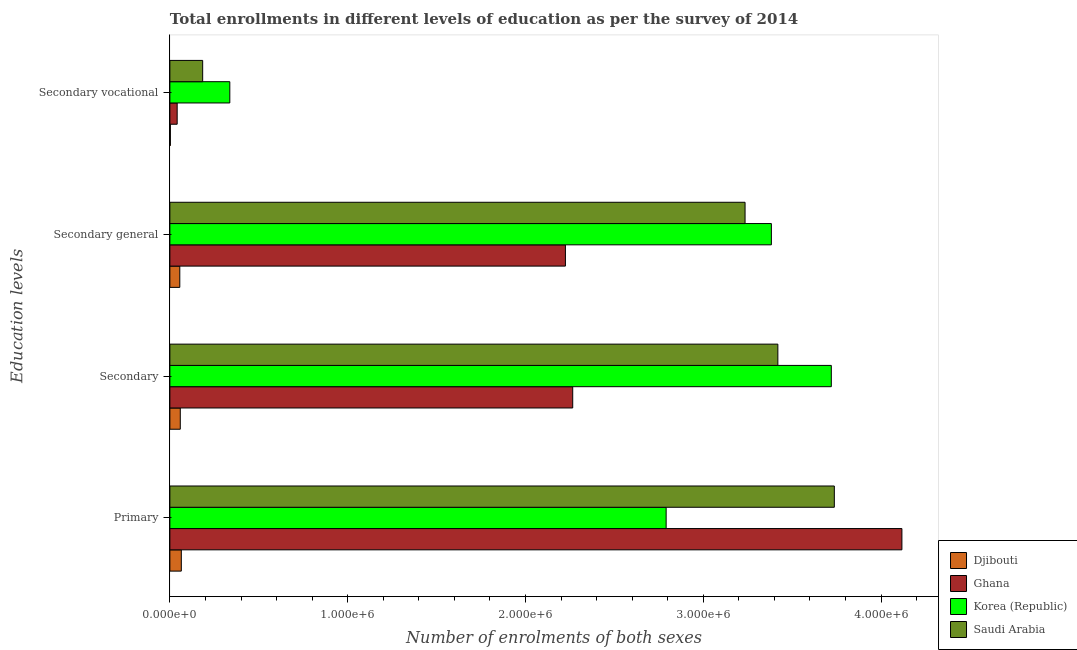How many different coloured bars are there?
Offer a terse response. 4. Are the number of bars per tick equal to the number of legend labels?
Provide a short and direct response. Yes. Are the number of bars on each tick of the Y-axis equal?
Keep it short and to the point. Yes. How many bars are there on the 4th tick from the top?
Ensure brevity in your answer.  4. What is the label of the 3rd group of bars from the top?
Keep it short and to the point. Secondary. What is the number of enrolments in secondary vocational education in Djibouti?
Your answer should be compact. 2728. Across all countries, what is the maximum number of enrolments in secondary education?
Provide a succinct answer. 3.72e+06. Across all countries, what is the minimum number of enrolments in primary education?
Give a very brief answer. 6.43e+04. In which country was the number of enrolments in secondary education maximum?
Your answer should be compact. Korea (Republic). In which country was the number of enrolments in secondary education minimum?
Provide a short and direct response. Djibouti. What is the total number of enrolments in primary education in the graph?
Provide a succinct answer. 1.07e+07. What is the difference between the number of enrolments in secondary education in Ghana and that in Korea (Republic)?
Make the answer very short. -1.45e+06. What is the difference between the number of enrolments in primary education in Djibouti and the number of enrolments in secondary vocational education in Korea (Republic)?
Ensure brevity in your answer.  -2.73e+05. What is the average number of enrolments in primary education per country?
Your response must be concise. 2.68e+06. What is the difference between the number of enrolments in secondary vocational education and number of enrolments in secondary education in Korea (Republic)?
Your answer should be compact. -3.38e+06. What is the ratio of the number of enrolments in primary education in Korea (Republic) to that in Djibouti?
Provide a short and direct response. 43.4. Is the number of enrolments in secondary general education in Djibouti less than that in Ghana?
Keep it short and to the point. Yes. Is the difference between the number of enrolments in primary education in Ghana and Korea (Republic) greater than the difference between the number of enrolments in secondary general education in Ghana and Korea (Republic)?
Keep it short and to the point. Yes. What is the difference between the highest and the second highest number of enrolments in secondary education?
Give a very brief answer. 3.01e+05. What is the difference between the highest and the lowest number of enrolments in secondary education?
Provide a short and direct response. 3.66e+06. What does the 4th bar from the bottom in Secondary vocational represents?
Offer a very short reply. Saudi Arabia. Is it the case that in every country, the sum of the number of enrolments in primary education and number of enrolments in secondary education is greater than the number of enrolments in secondary general education?
Give a very brief answer. Yes. Are the values on the major ticks of X-axis written in scientific E-notation?
Offer a very short reply. Yes. Where does the legend appear in the graph?
Offer a terse response. Bottom right. How are the legend labels stacked?
Ensure brevity in your answer.  Vertical. What is the title of the graph?
Your answer should be very brief. Total enrollments in different levels of education as per the survey of 2014. What is the label or title of the X-axis?
Offer a very short reply. Number of enrolments of both sexes. What is the label or title of the Y-axis?
Ensure brevity in your answer.  Education levels. What is the Number of enrolments of both sexes in Djibouti in Primary?
Your answer should be very brief. 6.43e+04. What is the Number of enrolments of both sexes of Ghana in Primary?
Offer a very short reply. 4.12e+06. What is the Number of enrolments of both sexes of Korea (Republic) in Primary?
Make the answer very short. 2.79e+06. What is the Number of enrolments of both sexes in Saudi Arabia in Primary?
Give a very brief answer. 3.74e+06. What is the Number of enrolments of both sexes in Djibouti in Secondary?
Your answer should be very brief. 5.86e+04. What is the Number of enrolments of both sexes in Ghana in Secondary?
Your answer should be very brief. 2.27e+06. What is the Number of enrolments of both sexes of Korea (Republic) in Secondary?
Offer a terse response. 3.72e+06. What is the Number of enrolments of both sexes in Saudi Arabia in Secondary?
Keep it short and to the point. 3.42e+06. What is the Number of enrolments of both sexes of Djibouti in Secondary general?
Keep it short and to the point. 5.58e+04. What is the Number of enrolments of both sexes of Ghana in Secondary general?
Your answer should be compact. 2.22e+06. What is the Number of enrolments of both sexes in Korea (Republic) in Secondary general?
Your answer should be compact. 3.38e+06. What is the Number of enrolments of both sexes of Saudi Arabia in Secondary general?
Your answer should be compact. 3.24e+06. What is the Number of enrolments of both sexes of Djibouti in Secondary vocational?
Offer a terse response. 2728. What is the Number of enrolments of both sexes of Ghana in Secondary vocational?
Keep it short and to the point. 4.11e+04. What is the Number of enrolments of both sexes in Korea (Republic) in Secondary vocational?
Offer a terse response. 3.37e+05. What is the Number of enrolments of both sexes in Saudi Arabia in Secondary vocational?
Provide a succinct answer. 1.84e+05. Across all Education levels, what is the maximum Number of enrolments of both sexes of Djibouti?
Give a very brief answer. 6.43e+04. Across all Education levels, what is the maximum Number of enrolments of both sexes of Ghana?
Keep it short and to the point. 4.12e+06. Across all Education levels, what is the maximum Number of enrolments of both sexes in Korea (Republic)?
Your response must be concise. 3.72e+06. Across all Education levels, what is the maximum Number of enrolments of both sexes in Saudi Arabia?
Provide a succinct answer. 3.74e+06. Across all Education levels, what is the minimum Number of enrolments of both sexes in Djibouti?
Offer a terse response. 2728. Across all Education levels, what is the minimum Number of enrolments of both sexes in Ghana?
Your answer should be compact. 4.11e+04. Across all Education levels, what is the minimum Number of enrolments of both sexes of Korea (Republic)?
Provide a succinct answer. 3.37e+05. Across all Education levels, what is the minimum Number of enrolments of both sexes of Saudi Arabia?
Your answer should be compact. 1.84e+05. What is the total Number of enrolments of both sexes of Djibouti in the graph?
Offer a very short reply. 1.81e+05. What is the total Number of enrolments of both sexes in Ghana in the graph?
Offer a very short reply. 8.65e+06. What is the total Number of enrolments of both sexes of Korea (Republic) in the graph?
Provide a short and direct response. 1.02e+07. What is the total Number of enrolments of both sexes of Saudi Arabia in the graph?
Provide a short and direct response. 1.06e+07. What is the difference between the Number of enrolments of both sexes in Djibouti in Primary and that in Secondary?
Offer a terse response. 5766. What is the difference between the Number of enrolments of both sexes of Ghana in Primary and that in Secondary?
Provide a short and direct response. 1.85e+06. What is the difference between the Number of enrolments of both sexes of Korea (Republic) in Primary and that in Secondary?
Offer a terse response. -9.29e+05. What is the difference between the Number of enrolments of both sexes of Saudi Arabia in Primary and that in Secondary?
Keep it short and to the point. 3.18e+05. What is the difference between the Number of enrolments of both sexes in Djibouti in Primary and that in Secondary general?
Provide a succinct answer. 8494. What is the difference between the Number of enrolments of both sexes of Ghana in Primary and that in Secondary general?
Provide a succinct answer. 1.89e+06. What is the difference between the Number of enrolments of both sexes of Korea (Republic) in Primary and that in Secondary general?
Offer a very short reply. -5.92e+05. What is the difference between the Number of enrolments of both sexes of Saudi Arabia in Primary and that in Secondary general?
Provide a succinct answer. 5.02e+05. What is the difference between the Number of enrolments of both sexes in Djibouti in Primary and that in Secondary vocational?
Your response must be concise. 6.16e+04. What is the difference between the Number of enrolments of both sexes of Ghana in Primary and that in Secondary vocational?
Make the answer very short. 4.08e+06. What is the difference between the Number of enrolments of both sexes in Korea (Republic) in Primary and that in Secondary vocational?
Offer a very short reply. 2.45e+06. What is the difference between the Number of enrolments of both sexes of Saudi Arabia in Primary and that in Secondary vocational?
Make the answer very short. 3.55e+06. What is the difference between the Number of enrolments of both sexes in Djibouti in Secondary and that in Secondary general?
Ensure brevity in your answer.  2728. What is the difference between the Number of enrolments of both sexes in Ghana in Secondary and that in Secondary general?
Your answer should be very brief. 4.11e+04. What is the difference between the Number of enrolments of both sexes of Korea (Republic) in Secondary and that in Secondary general?
Your answer should be compact. 3.37e+05. What is the difference between the Number of enrolments of both sexes in Saudi Arabia in Secondary and that in Secondary general?
Your response must be concise. 1.84e+05. What is the difference between the Number of enrolments of both sexes in Djibouti in Secondary and that in Secondary vocational?
Ensure brevity in your answer.  5.58e+04. What is the difference between the Number of enrolments of both sexes in Ghana in Secondary and that in Secondary vocational?
Keep it short and to the point. 2.22e+06. What is the difference between the Number of enrolments of both sexes in Korea (Republic) in Secondary and that in Secondary vocational?
Ensure brevity in your answer.  3.38e+06. What is the difference between the Number of enrolments of both sexes of Saudi Arabia in Secondary and that in Secondary vocational?
Your response must be concise. 3.24e+06. What is the difference between the Number of enrolments of both sexes of Djibouti in Secondary general and that in Secondary vocational?
Make the answer very short. 5.31e+04. What is the difference between the Number of enrolments of both sexes in Ghana in Secondary general and that in Secondary vocational?
Keep it short and to the point. 2.18e+06. What is the difference between the Number of enrolments of both sexes in Korea (Republic) in Secondary general and that in Secondary vocational?
Your response must be concise. 3.05e+06. What is the difference between the Number of enrolments of both sexes of Saudi Arabia in Secondary general and that in Secondary vocational?
Offer a very short reply. 3.05e+06. What is the difference between the Number of enrolments of both sexes of Djibouti in Primary and the Number of enrolments of both sexes of Ghana in Secondary?
Keep it short and to the point. -2.20e+06. What is the difference between the Number of enrolments of both sexes of Djibouti in Primary and the Number of enrolments of both sexes of Korea (Republic) in Secondary?
Your answer should be very brief. -3.66e+06. What is the difference between the Number of enrolments of both sexes of Djibouti in Primary and the Number of enrolments of both sexes of Saudi Arabia in Secondary?
Provide a succinct answer. -3.36e+06. What is the difference between the Number of enrolments of both sexes in Ghana in Primary and the Number of enrolments of both sexes in Korea (Republic) in Secondary?
Keep it short and to the point. 3.97e+05. What is the difference between the Number of enrolments of both sexes in Ghana in Primary and the Number of enrolments of both sexes in Saudi Arabia in Secondary?
Your response must be concise. 6.98e+05. What is the difference between the Number of enrolments of both sexes in Korea (Republic) in Primary and the Number of enrolments of both sexes in Saudi Arabia in Secondary?
Make the answer very short. -6.28e+05. What is the difference between the Number of enrolments of both sexes of Djibouti in Primary and the Number of enrolments of both sexes of Ghana in Secondary general?
Your response must be concise. -2.16e+06. What is the difference between the Number of enrolments of both sexes of Djibouti in Primary and the Number of enrolments of both sexes of Korea (Republic) in Secondary general?
Provide a succinct answer. -3.32e+06. What is the difference between the Number of enrolments of both sexes in Djibouti in Primary and the Number of enrolments of both sexes in Saudi Arabia in Secondary general?
Offer a very short reply. -3.17e+06. What is the difference between the Number of enrolments of both sexes in Ghana in Primary and the Number of enrolments of both sexes in Korea (Republic) in Secondary general?
Keep it short and to the point. 7.34e+05. What is the difference between the Number of enrolments of both sexes in Ghana in Primary and the Number of enrolments of both sexes in Saudi Arabia in Secondary general?
Keep it short and to the point. 8.82e+05. What is the difference between the Number of enrolments of both sexes in Korea (Republic) in Primary and the Number of enrolments of both sexes in Saudi Arabia in Secondary general?
Give a very brief answer. -4.44e+05. What is the difference between the Number of enrolments of both sexes in Djibouti in Primary and the Number of enrolments of both sexes in Ghana in Secondary vocational?
Give a very brief answer. 2.33e+04. What is the difference between the Number of enrolments of both sexes of Djibouti in Primary and the Number of enrolments of both sexes of Korea (Republic) in Secondary vocational?
Your answer should be compact. -2.73e+05. What is the difference between the Number of enrolments of both sexes in Djibouti in Primary and the Number of enrolments of both sexes in Saudi Arabia in Secondary vocational?
Offer a very short reply. -1.20e+05. What is the difference between the Number of enrolments of both sexes in Ghana in Primary and the Number of enrolments of both sexes in Korea (Republic) in Secondary vocational?
Provide a succinct answer. 3.78e+06. What is the difference between the Number of enrolments of both sexes in Ghana in Primary and the Number of enrolments of both sexes in Saudi Arabia in Secondary vocational?
Offer a terse response. 3.93e+06. What is the difference between the Number of enrolments of both sexes in Korea (Republic) in Primary and the Number of enrolments of both sexes in Saudi Arabia in Secondary vocational?
Ensure brevity in your answer.  2.61e+06. What is the difference between the Number of enrolments of both sexes of Djibouti in Secondary and the Number of enrolments of both sexes of Ghana in Secondary general?
Keep it short and to the point. -2.17e+06. What is the difference between the Number of enrolments of both sexes of Djibouti in Secondary and the Number of enrolments of both sexes of Korea (Republic) in Secondary general?
Make the answer very short. -3.32e+06. What is the difference between the Number of enrolments of both sexes in Djibouti in Secondary and the Number of enrolments of both sexes in Saudi Arabia in Secondary general?
Keep it short and to the point. -3.18e+06. What is the difference between the Number of enrolments of both sexes of Ghana in Secondary and the Number of enrolments of both sexes of Korea (Republic) in Secondary general?
Offer a terse response. -1.12e+06. What is the difference between the Number of enrolments of both sexes of Ghana in Secondary and the Number of enrolments of both sexes of Saudi Arabia in Secondary general?
Ensure brevity in your answer.  -9.69e+05. What is the difference between the Number of enrolments of both sexes of Korea (Republic) in Secondary and the Number of enrolments of both sexes of Saudi Arabia in Secondary general?
Make the answer very short. 4.85e+05. What is the difference between the Number of enrolments of both sexes of Djibouti in Secondary and the Number of enrolments of both sexes of Ghana in Secondary vocational?
Ensure brevity in your answer.  1.75e+04. What is the difference between the Number of enrolments of both sexes of Djibouti in Secondary and the Number of enrolments of both sexes of Korea (Republic) in Secondary vocational?
Provide a succinct answer. -2.79e+05. What is the difference between the Number of enrolments of both sexes in Djibouti in Secondary and the Number of enrolments of both sexes in Saudi Arabia in Secondary vocational?
Offer a very short reply. -1.26e+05. What is the difference between the Number of enrolments of both sexes in Ghana in Secondary and the Number of enrolments of both sexes in Korea (Republic) in Secondary vocational?
Your answer should be compact. 1.93e+06. What is the difference between the Number of enrolments of both sexes of Ghana in Secondary and the Number of enrolments of both sexes of Saudi Arabia in Secondary vocational?
Ensure brevity in your answer.  2.08e+06. What is the difference between the Number of enrolments of both sexes in Korea (Republic) in Secondary and the Number of enrolments of both sexes in Saudi Arabia in Secondary vocational?
Provide a short and direct response. 3.54e+06. What is the difference between the Number of enrolments of both sexes of Djibouti in Secondary general and the Number of enrolments of both sexes of Ghana in Secondary vocational?
Give a very brief answer. 1.48e+04. What is the difference between the Number of enrolments of both sexes of Djibouti in Secondary general and the Number of enrolments of both sexes of Korea (Republic) in Secondary vocational?
Offer a very short reply. -2.81e+05. What is the difference between the Number of enrolments of both sexes in Djibouti in Secondary general and the Number of enrolments of both sexes in Saudi Arabia in Secondary vocational?
Your answer should be compact. -1.29e+05. What is the difference between the Number of enrolments of both sexes in Ghana in Secondary general and the Number of enrolments of both sexes in Korea (Republic) in Secondary vocational?
Your response must be concise. 1.89e+06. What is the difference between the Number of enrolments of both sexes in Ghana in Secondary general and the Number of enrolments of both sexes in Saudi Arabia in Secondary vocational?
Your answer should be compact. 2.04e+06. What is the difference between the Number of enrolments of both sexes of Korea (Republic) in Secondary general and the Number of enrolments of both sexes of Saudi Arabia in Secondary vocational?
Keep it short and to the point. 3.20e+06. What is the average Number of enrolments of both sexes of Djibouti per Education levels?
Offer a terse response. 4.54e+04. What is the average Number of enrolments of both sexes of Ghana per Education levels?
Make the answer very short. 2.16e+06. What is the average Number of enrolments of both sexes in Korea (Republic) per Education levels?
Give a very brief answer. 2.56e+06. What is the average Number of enrolments of both sexes in Saudi Arabia per Education levels?
Provide a short and direct response. 2.64e+06. What is the difference between the Number of enrolments of both sexes of Djibouti and Number of enrolments of both sexes of Ghana in Primary?
Provide a short and direct response. -4.05e+06. What is the difference between the Number of enrolments of both sexes of Djibouti and Number of enrolments of both sexes of Korea (Republic) in Primary?
Make the answer very short. -2.73e+06. What is the difference between the Number of enrolments of both sexes of Djibouti and Number of enrolments of both sexes of Saudi Arabia in Primary?
Offer a terse response. -3.67e+06. What is the difference between the Number of enrolments of both sexes in Ghana and Number of enrolments of both sexes in Korea (Republic) in Primary?
Make the answer very short. 1.33e+06. What is the difference between the Number of enrolments of both sexes in Ghana and Number of enrolments of both sexes in Saudi Arabia in Primary?
Make the answer very short. 3.80e+05. What is the difference between the Number of enrolments of both sexes in Korea (Republic) and Number of enrolments of both sexes in Saudi Arabia in Primary?
Make the answer very short. -9.46e+05. What is the difference between the Number of enrolments of both sexes in Djibouti and Number of enrolments of both sexes in Ghana in Secondary?
Give a very brief answer. -2.21e+06. What is the difference between the Number of enrolments of both sexes in Djibouti and Number of enrolments of both sexes in Korea (Republic) in Secondary?
Your answer should be compact. -3.66e+06. What is the difference between the Number of enrolments of both sexes in Djibouti and Number of enrolments of both sexes in Saudi Arabia in Secondary?
Your answer should be very brief. -3.36e+06. What is the difference between the Number of enrolments of both sexes in Ghana and Number of enrolments of both sexes in Korea (Republic) in Secondary?
Ensure brevity in your answer.  -1.45e+06. What is the difference between the Number of enrolments of both sexes in Ghana and Number of enrolments of both sexes in Saudi Arabia in Secondary?
Your response must be concise. -1.15e+06. What is the difference between the Number of enrolments of both sexes in Korea (Republic) and Number of enrolments of both sexes in Saudi Arabia in Secondary?
Ensure brevity in your answer.  3.01e+05. What is the difference between the Number of enrolments of both sexes of Djibouti and Number of enrolments of both sexes of Ghana in Secondary general?
Provide a succinct answer. -2.17e+06. What is the difference between the Number of enrolments of both sexes in Djibouti and Number of enrolments of both sexes in Korea (Republic) in Secondary general?
Your answer should be very brief. -3.33e+06. What is the difference between the Number of enrolments of both sexes in Djibouti and Number of enrolments of both sexes in Saudi Arabia in Secondary general?
Ensure brevity in your answer.  -3.18e+06. What is the difference between the Number of enrolments of both sexes in Ghana and Number of enrolments of both sexes in Korea (Republic) in Secondary general?
Your answer should be very brief. -1.16e+06. What is the difference between the Number of enrolments of both sexes in Ghana and Number of enrolments of both sexes in Saudi Arabia in Secondary general?
Give a very brief answer. -1.01e+06. What is the difference between the Number of enrolments of both sexes in Korea (Republic) and Number of enrolments of both sexes in Saudi Arabia in Secondary general?
Your answer should be very brief. 1.48e+05. What is the difference between the Number of enrolments of both sexes in Djibouti and Number of enrolments of both sexes in Ghana in Secondary vocational?
Your answer should be compact. -3.83e+04. What is the difference between the Number of enrolments of both sexes in Djibouti and Number of enrolments of both sexes in Korea (Republic) in Secondary vocational?
Offer a terse response. -3.34e+05. What is the difference between the Number of enrolments of both sexes of Djibouti and Number of enrolments of both sexes of Saudi Arabia in Secondary vocational?
Ensure brevity in your answer.  -1.82e+05. What is the difference between the Number of enrolments of both sexes of Ghana and Number of enrolments of both sexes of Korea (Republic) in Secondary vocational?
Your answer should be compact. -2.96e+05. What is the difference between the Number of enrolments of both sexes of Ghana and Number of enrolments of both sexes of Saudi Arabia in Secondary vocational?
Your response must be concise. -1.43e+05. What is the difference between the Number of enrolments of both sexes of Korea (Republic) and Number of enrolments of both sexes of Saudi Arabia in Secondary vocational?
Keep it short and to the point. 1.53e+05. What is the ratio of the Number of enrolments of both sexes of Djibouti in Primary to that in Secondary?
Offer a terse response. 1.1. What is the ratio of the Number of enrolments of both sexes in Ghana in Primary to that in Secondary?
Keep it short and to the point. 1.82. What is the ratio of the Number of enrolments of both sexes of Korea (Republic) in Primary to that in Secondary?
Your response must be concise. 0.75. What is the ratio of the Number of enrolments of both sexes in Saudi Arabia in Primary to that in Secondary?
Your answer should be compact. 1.09. What is the ratio of the Number of enrolments of both sexes of Djibouti in Primary to that in Secondary general?
Ensure brevity in your answer.  1.15. What is the ratio of the Number of enrolments of both sexes of Ghana in Primary to that in Secondary general?
Make the answer very short. 1.85. What is the ratio of the Number of enrolments of both sexes in Korea (Republic) in Primary to that in Secondary general?
Provide a short and direct response. 0.83. What is the ratio of the Number of enrolments of both sexes in Saudi Arabia in Primary to that in Secondary general?
Give a very brief answer. 1.16. What is the ratio of the Number of enrolments of both sexes of Djibouti in Primary to that in Secondary vocational?
Provide a short and direct response. 23.58. What is the ratio of the Number of enrolments of both sexes of Ghana in Primary to that in Secondary vocational?
Your response must be concise. 100.26. What is the ratio of the Number of enrolments of both sexes in Korea (Republic) in Primary to that in Secondary vocational?
Your answer should be very brief. 8.28. What is the ratio of the Number of enrolments of both sexes of Saudi Arabia in Primary to that in Secondary vocational?
Offer a very short reply. 20.26. What is the ratio of the Number of enrolments of both sexes in Djibouti in Secondary to that in Secondary general?
Provide a succinct answer. 1.05. What is the ratio of the Number of enrolments of both sexes in Ghana in Secondary to that in Secondary general?
Offer a very short reply. 1.02. What is the ratio of the Number of enrolments of both sexes in Korea (Republic) in Secondary to that in Secondary general?
Ensure brevity in your answer.  1.1. What is the ratio of the Number of enrolments of both sexes of Saudi Arabia in Secondary to that in Secondary general?
Your answer should be very brief. 1.06. What is the ratio of the Number of enrolments of both sexes of Djibouti in Secondary to that in Secondary vocational?
Your answer should be compact. 21.46. What is the ratio of the Number of enrolments of both sexes in Ghana in Secondary to that in Secondary vocational?
Ensure brevity in your answer.  55.17. What is the ratio of the Number of enrolments of both sexes in Korea (Republic) in Secondary to that in Secondary vocational?
Ensure brevity in your answer.  11.03. What is the ratio of the Number of enrolments of both sexes in Saudi Arabia in Secondary to that in Secondary vocational?
Keep it short and to the point. 18.54. What is the ratio of the Number of enrolments of both sexes of Djibouti in Secondary general to that in Secondary vocational?
Offer a terse response. 20.46. What is the ratio of the Number of enrolments of both sexes of Ghana in Secondary general to that in Secondary vocational?
Your response must be concise. 54.17. What is the ratio of the Number of enrolments of both sexes in Korea (Republic) in Secondary general to that in Secondary vocational?
Provide a succinct answer. 10.03. What is the ratio of the Number of enrolments of both sexes in Saudi Arabia in Secondary general to that in Secondary vocational?
Give a very brief answer. 17.54. What is the difference between the highest and the second highest Number of enrolments of both sexes in Djibouti?
Offer a very short reply. 5766. What is the difference between the highest and the second highest Number of enrolments of both sexes in Ghana?
Give a very brief answer. 1.85e+06. What is the difference between the highest and the second highest Number of enrolments of both sexes in Korea (Republic)?
Ensure brevity in your answer.  3.37e+05. What is the difference between the highest and the second highest Number of enrolments of both sexes in Saudi Arabia?
Your answer should be compact. 3.18e+05. What is the difference between the highest and the lowest Number of enrolments of both sexes of Djibouti?
Keep it short and to the point. 6.16e+04. What is the difference between the highest and the lowest Number of enrolments of both sexes in Ghana?
Your answer should be very brief. 4.08e+06. What is the difference between the highest and the lowest Number of enrolments of both sexes in Korea (Republic)?
Offer a very short reply. 3.38e+06. What is the difference between the highest and the lowest Number of enrolments of both sexes of Saudi Arabia?
Provide a succinct answer. 3.55e+06. 